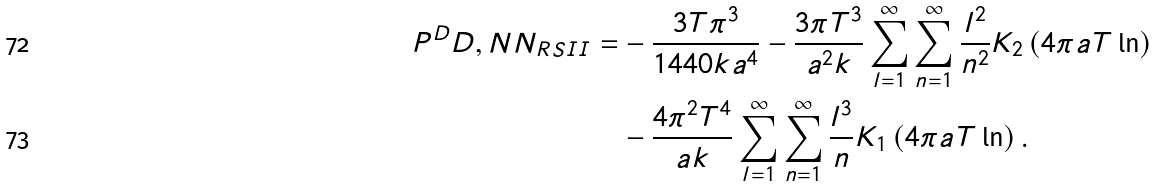Convert formula to latex. <formula><loc_0><loc_0><loc_500><loc_500>P ^ { D } D , N N _ { R S I I } = & - \frac { 3 T \pi ^ { 3 } } { 1 4 4 0 k a ^ { 4 } } - \frac { 3 \pi T ^ { 3 } } { a ^ { 2 } k } \sum _ { l = 1 } ^ { \infty } \sum _ { n = 1 } ^ { \infty } \frac { l ^ { 2 } } { n ^ { 2 } } K _ { 2 } \left ( 4 \pi a T \ln \right ) \\ & - \frac { 4 \pi ^ { 2 } T ^ { 4 } } { a k } \sum _ { l = 1 } ^ { \infty } \sum _ { n = 1 } ^ { \infty } \frac { l ^ { 3 } } { n } K _ { 1 } \left ( 4 \pi a T \ln \right ) .</formula> 